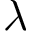<formula> <loc_0><loc_0><loc_500><loc_500>\lambda</formula> 